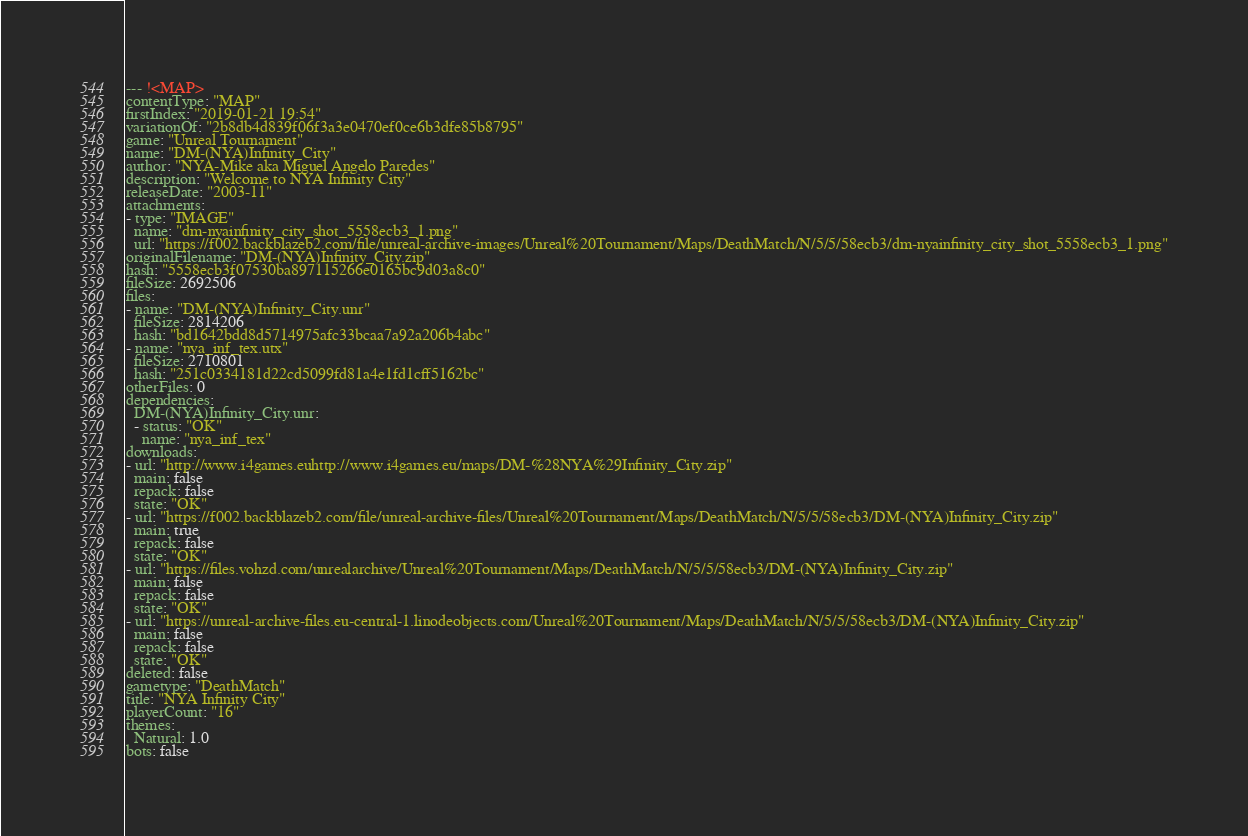<code> <loc_0><loc_0><loc_500><loc_500><_YAML_>--- !<MAP>
contentType: "MAP"
firstIndex: "2019-01-21 19:54"
variationOf: "2b8db4d839f06f3a3e0470ef0ce6b3dfe85b8795"
game: "Unreal Tournament"
name: "DM-(NYA)Infinity_City"
author: "NYA-Mike aka Miguel Angelo Paredes"
description: "Welcome to NYA Infinity City"
releaseDate: "2003-11"
attachments:
- type: "IMAGE"
  name: "dm-nyainfinity_city_shot_5558ecb3_1.png"
  url: "https://f002.backblazeb2.com/file/unreal-archive-images/Unreal%20Tournament/Maps/DeathMatch/N/5/5/58ecb3/dm-nyainfinity_city_shot_5558ecb3_1.png"
originalFilename: "DM-(NYA)Infinity_City.zip"
hash: "5558ecb3f07530ba897115266e0165bc9d03a8c0"
fileSize: 2692506
files:
- name: "DM-(NYA)Infinity_City.unr"
  fileSize: 2814206
  hash: "bd1642bdd8d5714975afc33bcaa7a92a206b4abc"
- name: "nya_inf_tex.utx"
  fileSize: 2710801
  hash: "251c0334181d22cd5099fd81a4e1fd1cff5162bc"
otherFiles: 0
dependencies:
  DM-(NYA)Infinity_City.unr:
  - status: "OK"
    name: "nya_inf_tex"
downloads:
- url: "http://www.i4games.euhttp://www.i4games.eu/maps/DM-%28NYA%29Infinity_City.zip"
  main: false
  repack: false
  state: "OK"
- url: "https://f002.backblazeb2.com/file/unreal-archive-files/Unreal%20Tournament/Maps/DeathMatch/N/5/5/58ecb3/DM-(NYA)Infinity_City.zip"
  main: true
  repack: false
  state: "OK"
- url: "https://files.vohzd.com/unrealarchive/Unreal%20Tournament/Maps/DeathMatch/N/5/5/58ecb3/DM-(NYA)Infinity_City.zip"
  main: false
  repack: false
  state: "OK"
- url: "https://unreal-archive-files.eu-central-1.linodeobjects.com/Unreal%20Tournament/Maps/DeathMatch/N/5/5/58ecb3/DM-(NYA)Infinity_City.zip"
  main: false
  repack: false
  state: "OK"
deleted: false
gametype: "DeathMatch"
title: "NYA Infinity City"
playerCount: "16"
themes:
  Natural: 1.0
bots: false
</code> 